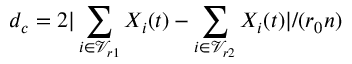Convert formula to latex. <formula><loc_0><loc_0><loc_500><loc_500>d _ { c } = 2 | \sum _ { i \in \mathcal { V } _ { r 1 } } X _ { i } ( t ) - \sum _ { i \in \mathcal { V } _ { r 2 } } X _ { i } ( t ) | / ( r _ { 0 } n )</formula> 